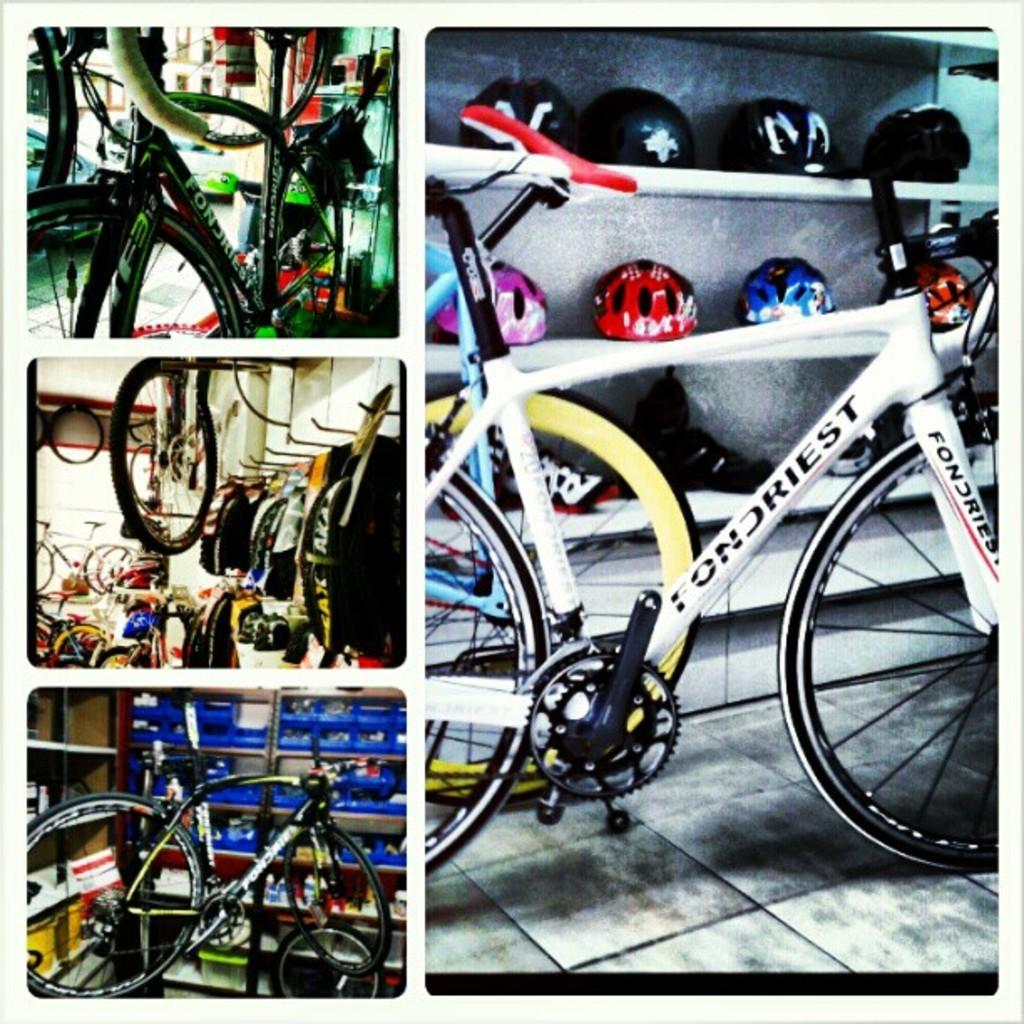What type of vehicles are present in the image? There are bicycles in the image. What safety equipment is associated with the bicycles in the image? There are helmets in the image. What type of lamp is hanging from the handlebars of the bicycles in the image? There are no lamps present on the bicycles in the image. 